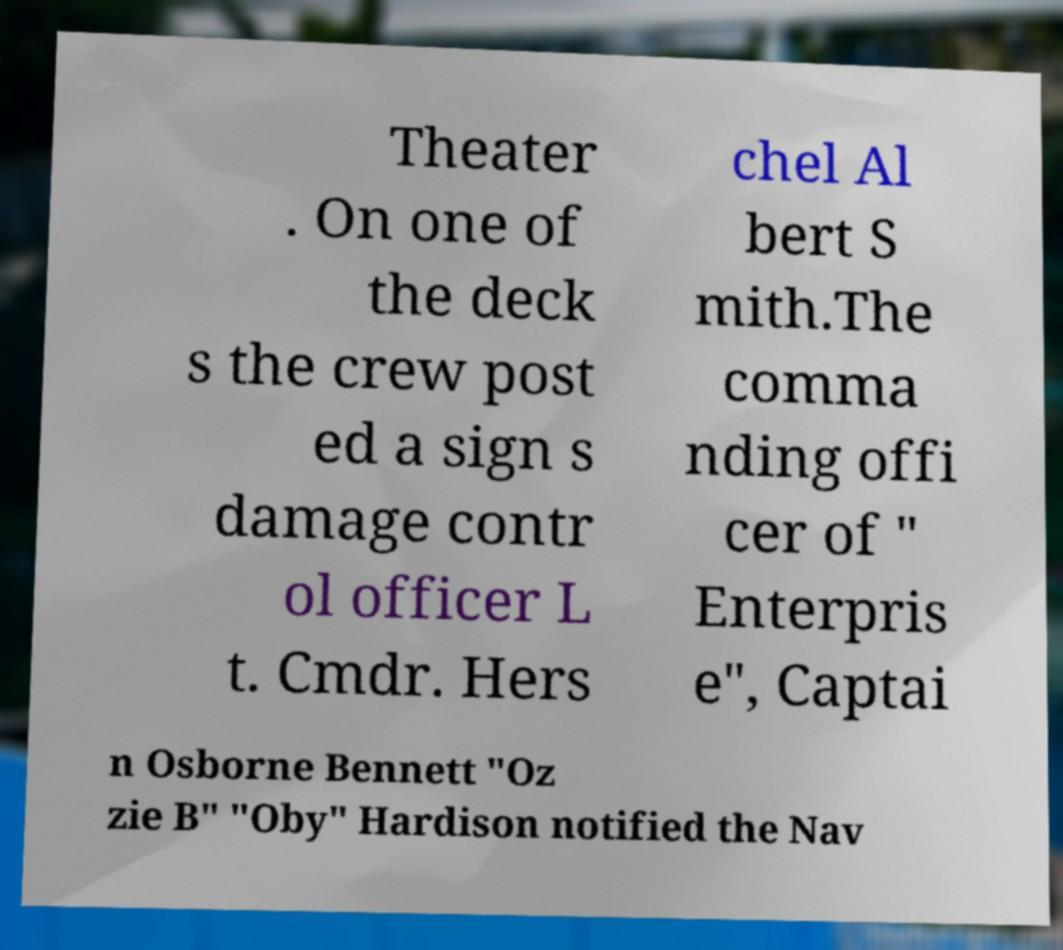Could you extract and type out the text from this image? Theater . On one of the deck s the crew post ed a sign s damage contr ol officer L t. Cmdr. Hers chel Al bert S mith.The comma nding offi cer of " Enterpris e", Captai n Osborne Bennett "Oz zie B" "Oby" Hardison notified the Nav 